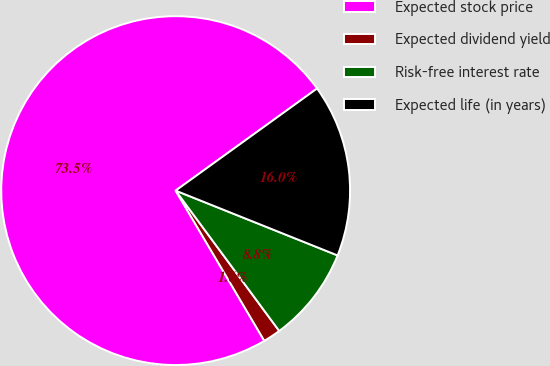<chart> <loc_0><loc_0><loc_500><loc_500><pie_chart><fcel>Expected stock price<fcel>Expected dividend yield<fcel>Risk-free interest rate<fcel>Expected life (in years)<nl><fcel>73.53%<fcel>1.63%<fcel>8.82%<fcel>16.01%<nl></chart> 